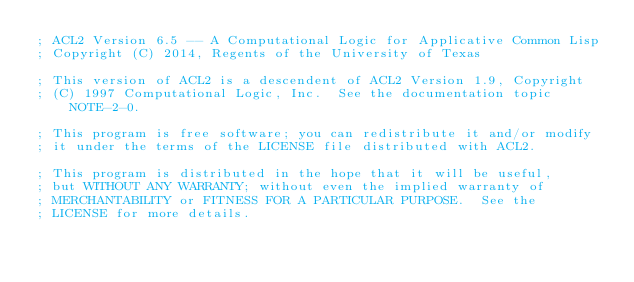Convert code to text. <code><loc_0><loc_0><loc_500><loc_500><_Lisp_>; ACL2 Version 6.5 -- A Computational Logic for Applicative Common Lisp
; Copyright (C) 2014, Regents of the University of Texas

; This version of ACL2 is a descendent of ACL2 Version 1.9, Copyright
; (C) 1997 Computational Logic, Inc.  See the documentation topic NOTE-2-0.

; This program is free software; you can redistribute it and/or modify
; it under the terms of the LICENSE file distributed with ACL2.

; This program is distributed in the hope that it will be useful,
; but WITHOUT ANY WARRANTY; without even the implied warranty of
; MERCHANTABILITY or FITNESS FOR A PARTICULAR PURPOSE.  See the
; LICENSE for more details.
</code> 